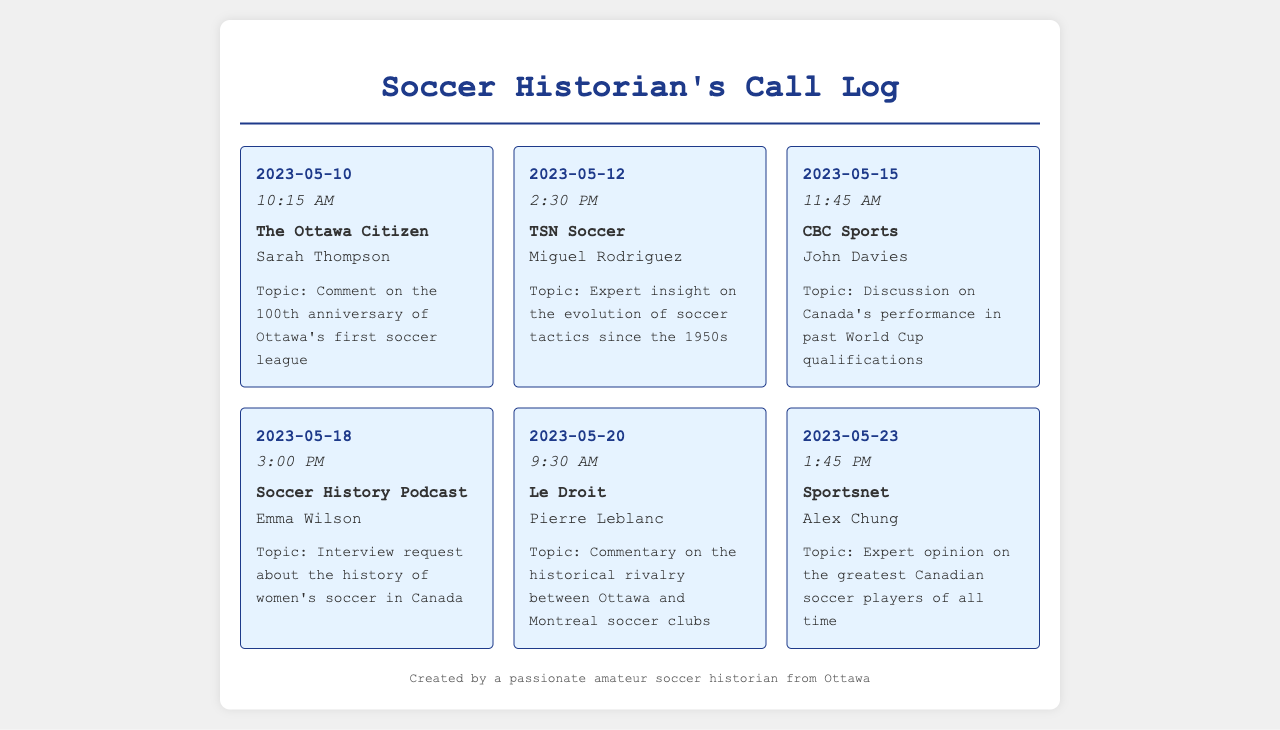what is the date of the call from The Ottawa Citizen? The call entry for The Ottawa Citizen shows the date as 2023-05-10.
Answer: 2023-05-10 who is the journalist that called from TSN Soccer? The call from TSN Soccer lists Miguel Rodriguez as the journalist who called.
Answer: Miguel Rodriguez what was the topic of the call from CBC Sports? The call entry from CBC Sports indicates the topic as Canada's performance in past World Cup qualifications.
Answer: Discussion on Canada's performance in past World Cup qualifications which organization sought commentary on Ottawa and Montreal soccer clubs? The call entry from Le Droit requested commentary on the historical rivalry between Ottawa and Montreal soccer clubs.
Answer: Le Droit how many calls were made during May 2023? The document lists a total of six call entries, all dated in May 2023.
Answer: 6 